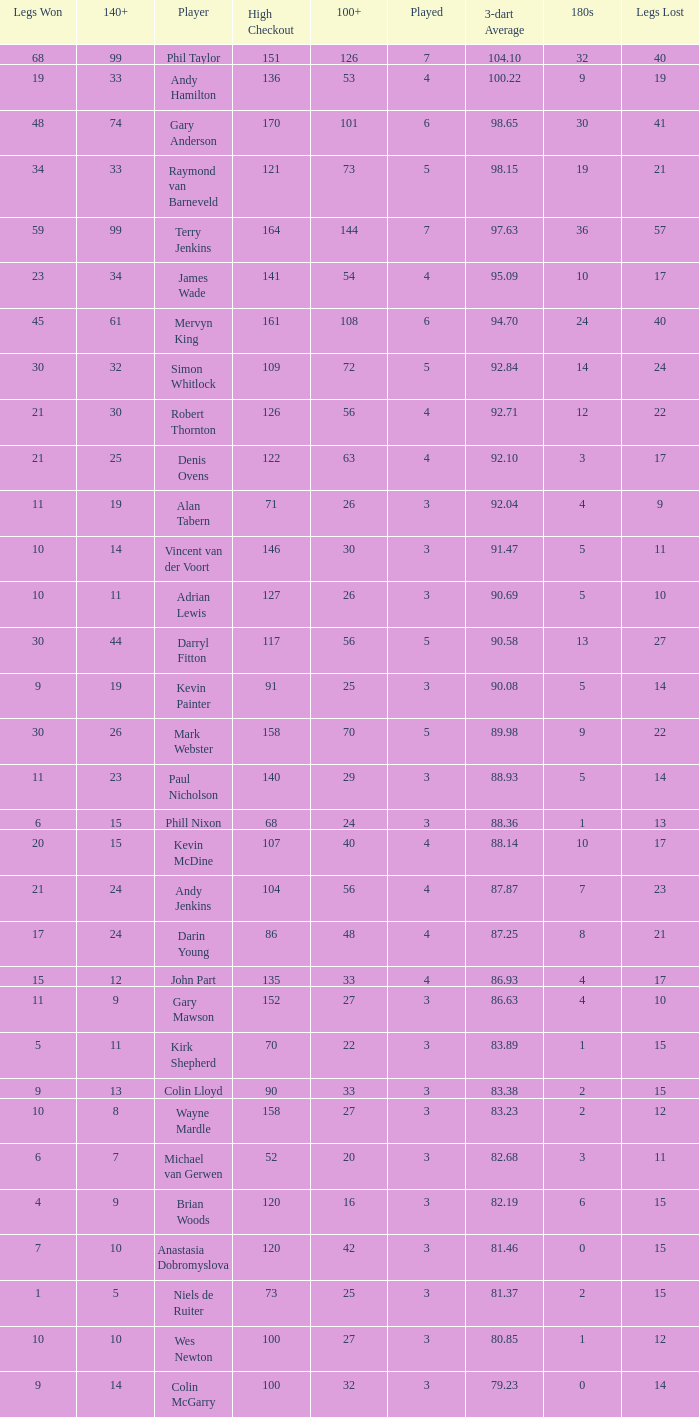What is the lowest high checkout when 140+ is 61, and played is larger than 6? None. 